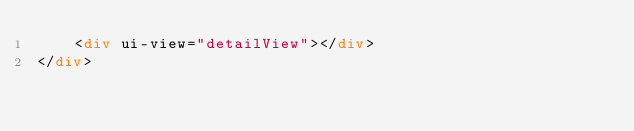Convert code to text. <code><loc_0><loc_0><loc_500><loc_500><_HTML_>    <div ui-view="detailView"></div>
</div>
</code> 